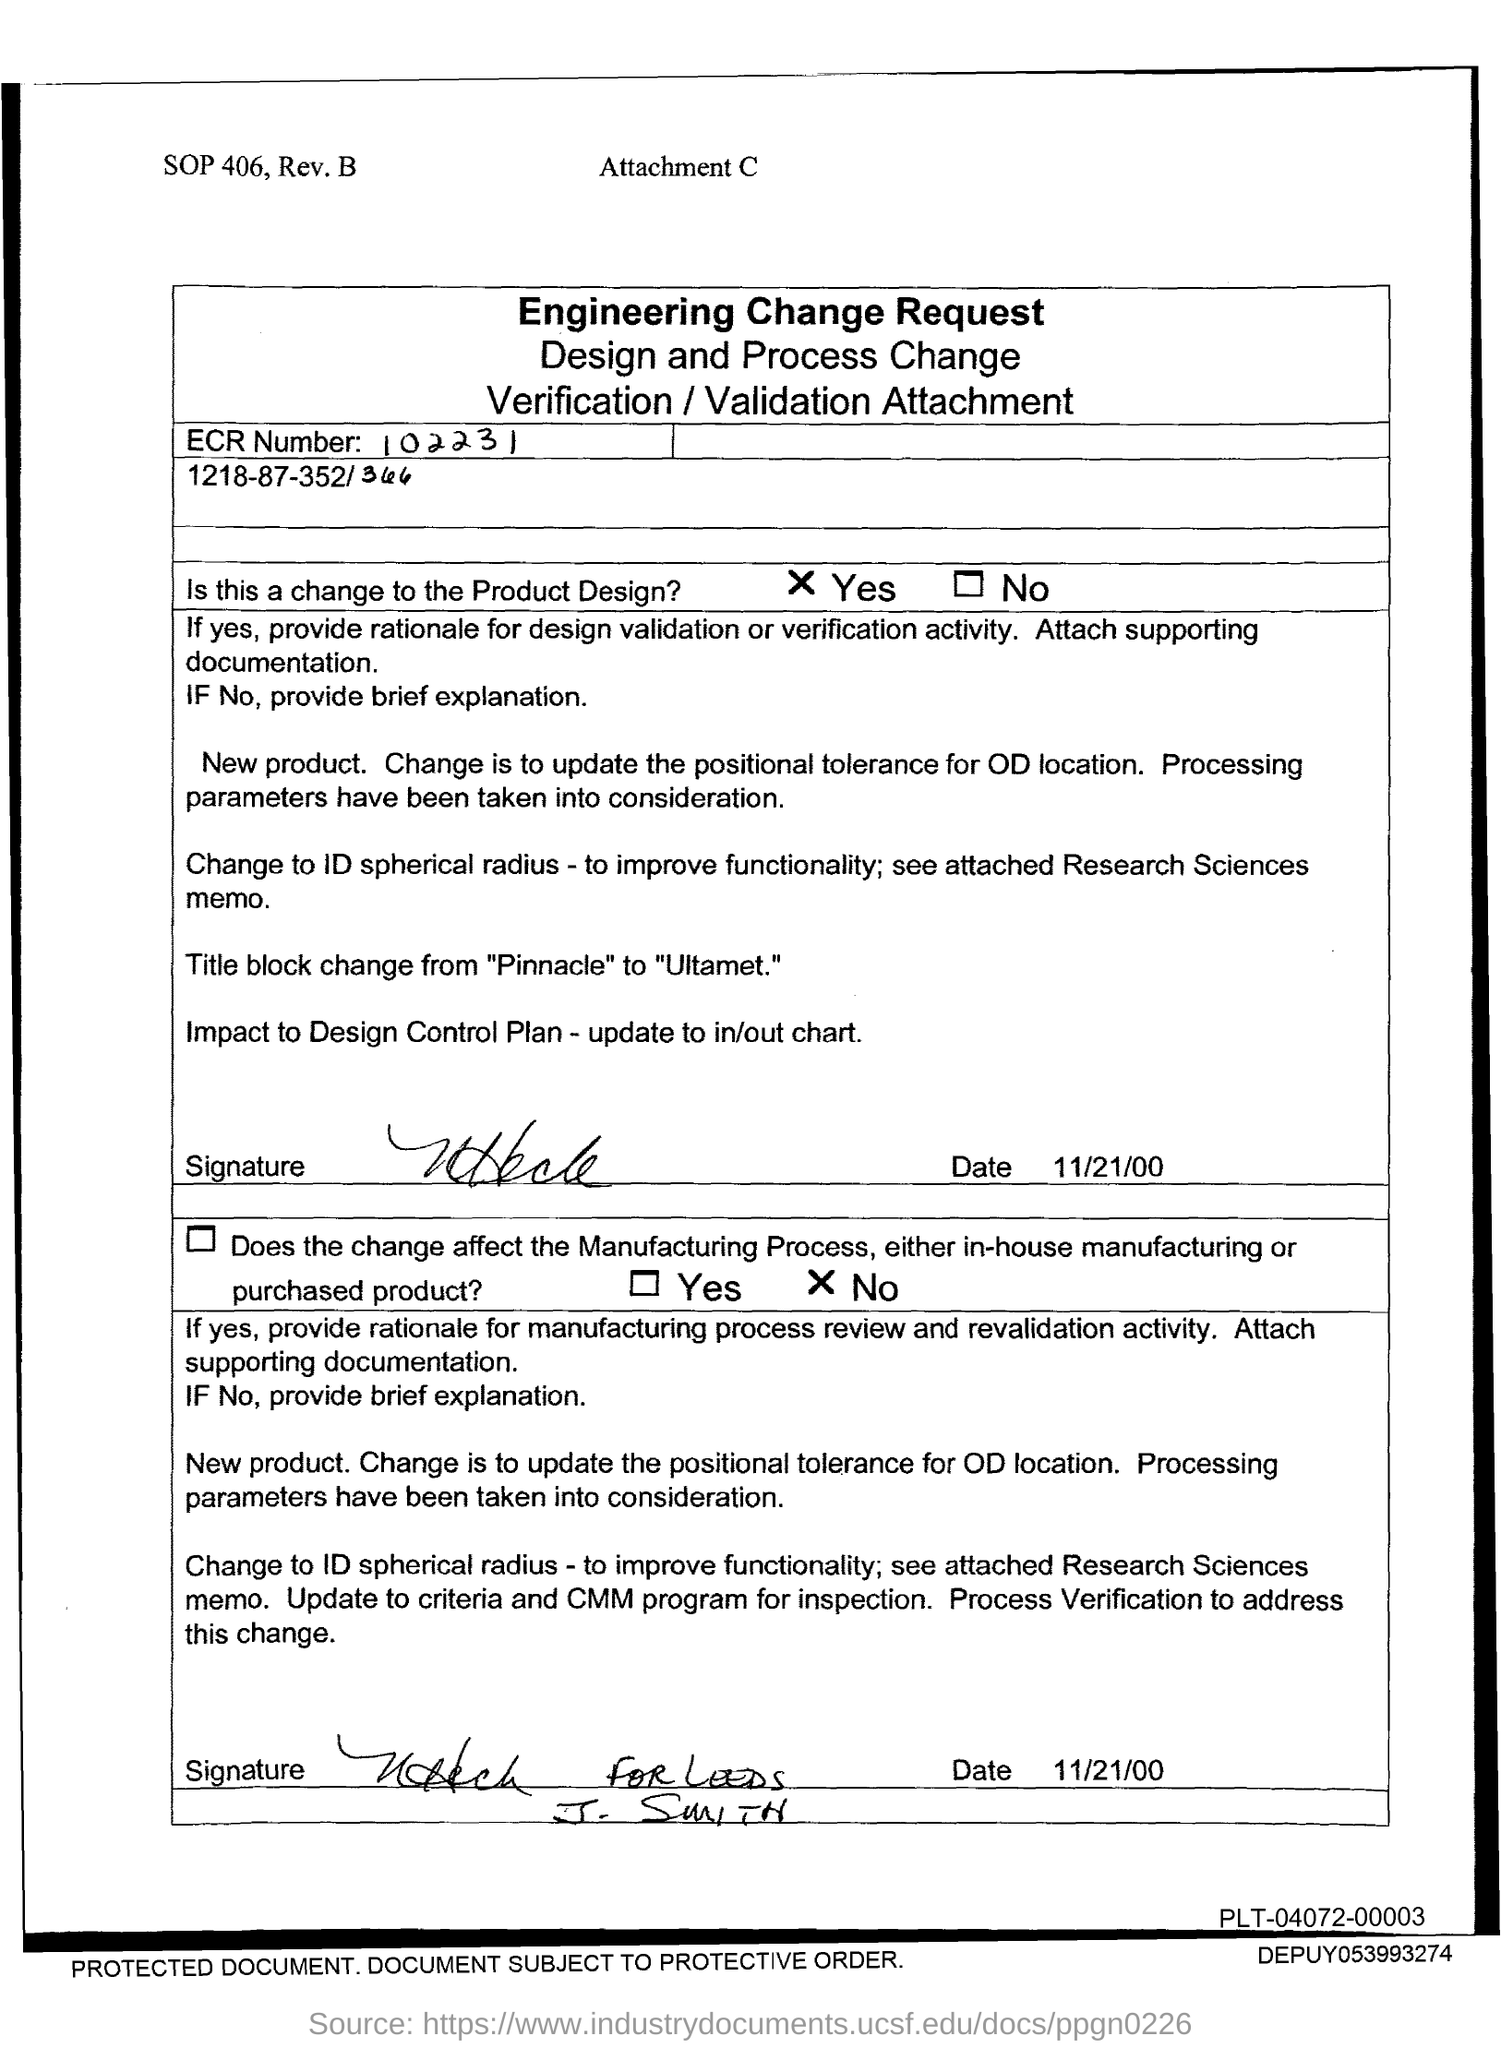What is the Date?
Provide a short and direct response. 11/21/00. 